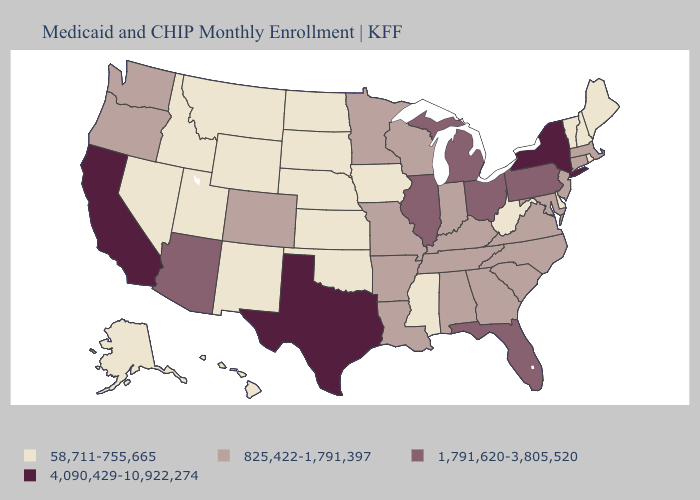Name the states that have a value in the range 1,791,620-3,805,520?
Short answer required. Arizona, Florida, Illinois, Michigan, Ohio, Pennsylvania. Does Kentucky have the highest value in the South?
Be succinct. No. What is the value of Minnesota?
Concise answer only. 825,422-1,791,397. Name the states that have a value in the range 58,711-755,665?
Answer briefly. Alaska, Delaware, Hawaii, Idaho, Iowa, Kansas, Maine, Mississippi, Montana, Nebraska, Nevada, New Hampshire, New Mexico, North Dakota, Oklahoma, Rhode Island, South Dakota, Utah, Vermont, West Virginia, Wyoming. Name the states that have a value in the range 4,090,429-10,922,274?
Quick response, please. California, New York, Texas. Which states have the lowest value in the South?
Be succinct. Delaware, Mississippi, Oklahoma, West Virginia. Does Kentucky have the lowest value in the USA?
Short answer required. No. Does the first symbol in the legend represent the smallest category?
Keep it brief. Yes. Which states have the lowest value in the South?
Keep it brief. Delaware, Mississippi, Oklahoma, West Virginia. What is the highest value in states that border Nevada?
Be succinct. 4,090,429-10,922,274. Among the states that border Rhode Island , which have the lowest value?
Answer briefly. Connecticut, Massachusetts. What is the highest value in states that border Mississippi?
Quick response, please. 825,422-1,791,397. How many symbols are there in the legend?
Be succinct. 4. Does Vermont have a lower value than Indiana?
Quick response, please. Yes. Which states have the lowest value in the USA?
Be succinct. Alaska, Delaware, Hawaii, Idaho, Iowa, Kansas, Maine, Mississippi, Montana, Nebraska, Nevada, New Hampshire, New Mexico, North Dakota, Oklahoma, Rhode Island, South Dakota, Utah, Vermont, West Virginia, Wyoming. 